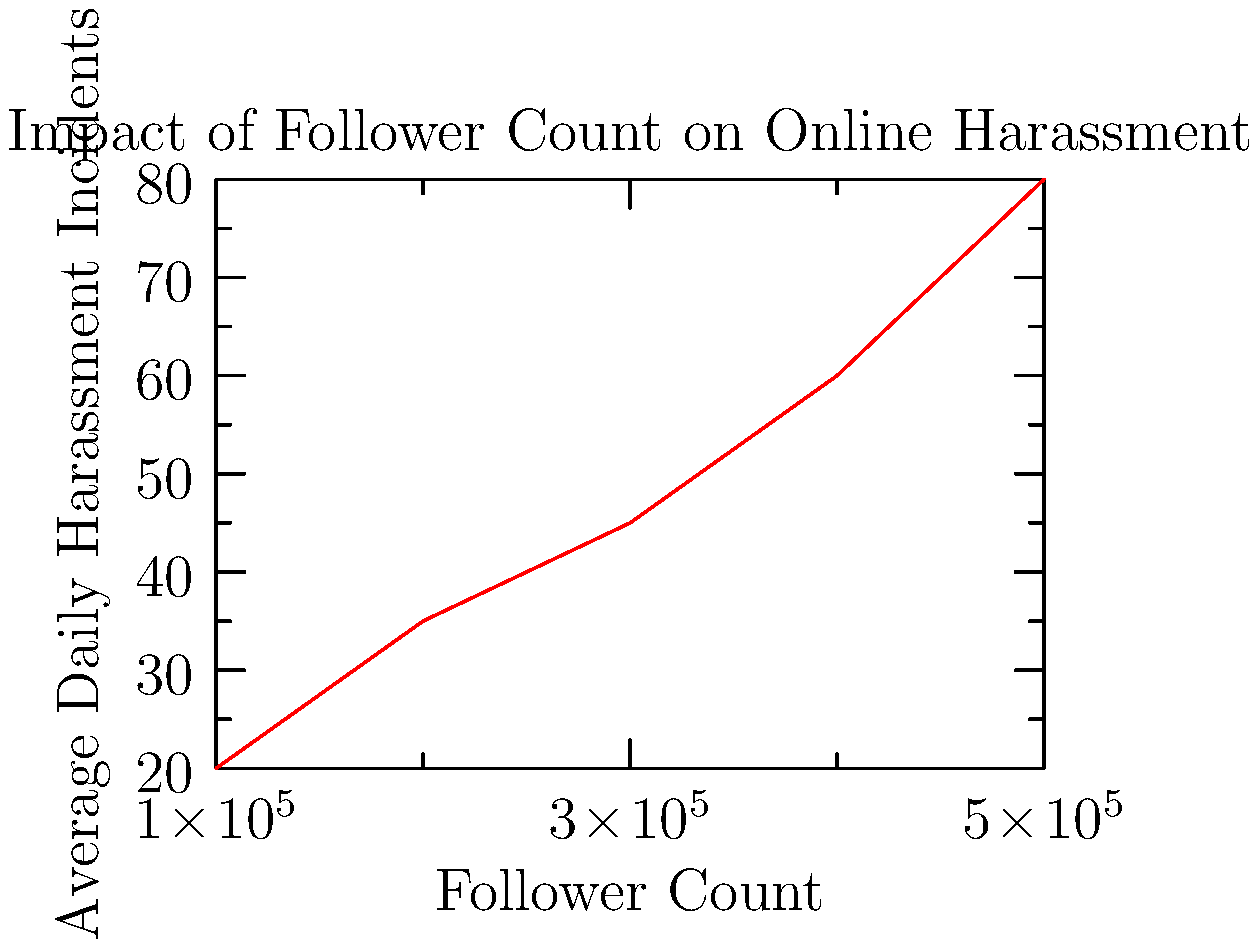Based on the line graph showing the relationship between follower count and average daily harassment incidents for social media influencers, calculate the rate of increase in harassment incidents per 100,000 followers. Round your answer to the nearest whole number. To calculate the rate of increase in harassment incidents per 100,000 followers, we need to:

1. Identify the starting and ending points on the graph:
   - Start: 100,000 followers, 20 incidents
   - End: 500,000 followers, 80 incidents

2. Calculate the total change in followers and incidents:
   - Follower change: 500,000 - 100,000 = 400,000
   - Incident change: 80 - 20 = 60

3. Set up the rate of change formula:
   $\text{Rate} = \frac{\text{Change in incidents}}{\text{Change in followers}} \times 100,000$

4. Plug in the values:
   $\text{Rate} = \frac{60}{400,000} \times 100,000$

5. Simplify:
   $\text{Rate} = 0.00015 \times 100,000 = 15$

6. Round to the nearest whole number: 15

Therefore, the rate of increase is approximately 15 harassment incidents per 100,000 followers.
Answer: 15 incidents per 100,000 followers 